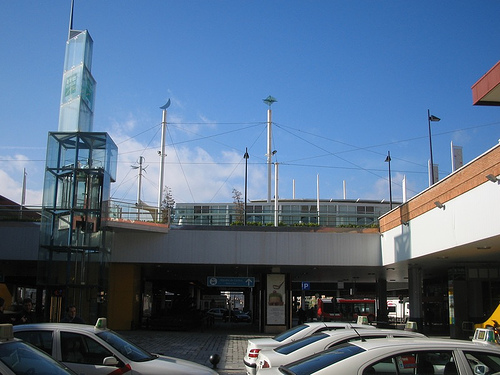<image>
Can you confirm if the sign is to the left of the car? Yes. From this viewpoint, the sign is positioned to the left side relative to the car. 